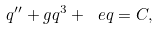<formula> <loc_0><loc_0><loc_500><loc_500>q ^ { \prime \prime } + g q ^ { 3 } + { \ e { q } } = C ,</formula> 